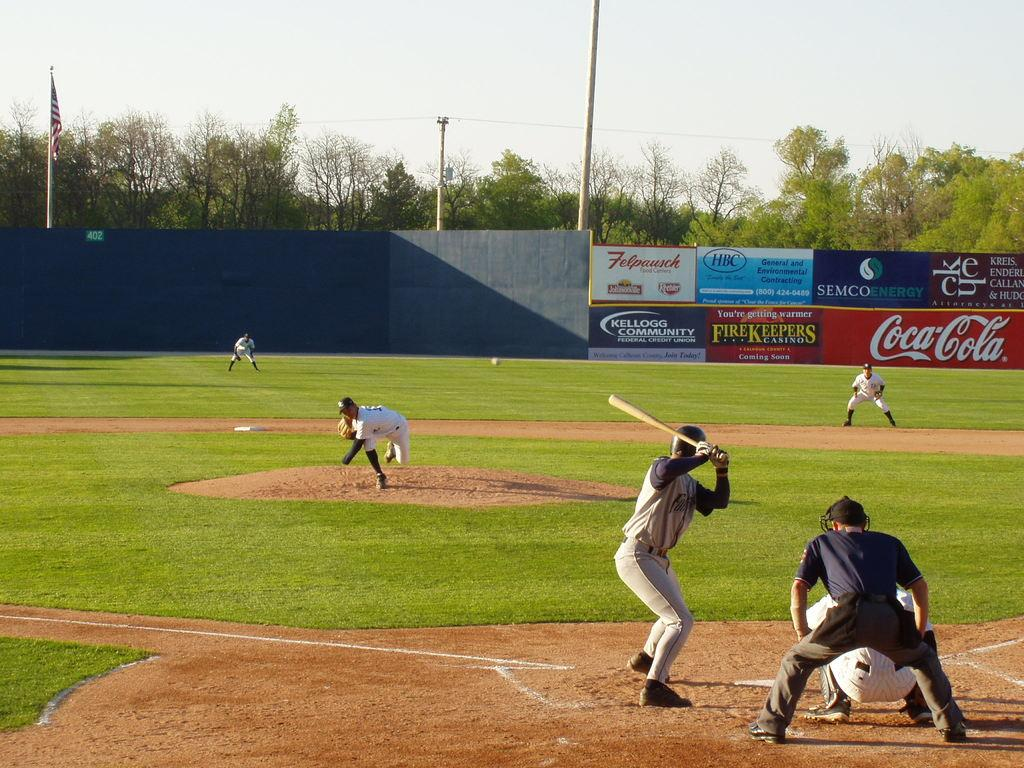<image>
Describe the image concisely. Baseball players play a game with a Fire Keepers sign in the backround on the stadium wall. 